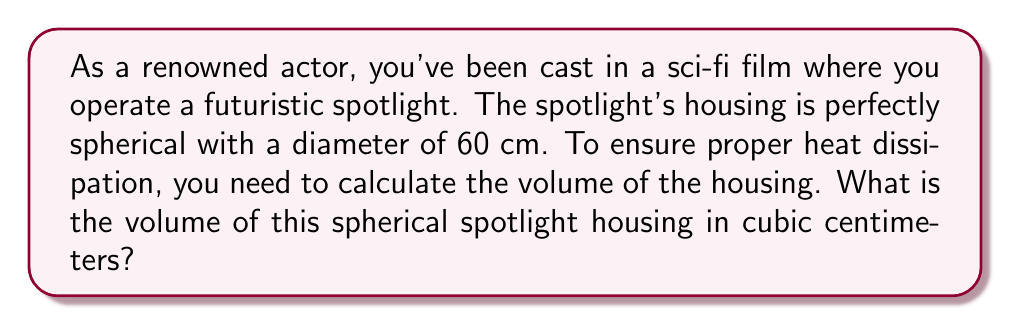Solve this math problem. Let's approach this step-by-step:

1) The formula for the volume of a sphere is:

   $$V = \frac{4}{3}\pi r^3$$

   where $r$ is the radius of the sphere.

2) We're given the diameter, which is 60 cm. The radius is half of this:

   $$r = \frac{60}{2} = 30 \text{ cm}$$

3) Now, let's substitute this into our volume formula:

   $$V = \frac{4}{3}\pi (30)^3$$

4) Simplify the exponent:

   $$V = \frac{4}{3}\pi (27000)$$

5) Multiply:

   $$V = 36000\pi$$

6) If we use $\pi \approx 3.14159$, we get:

   $$V \approx 113097.6 \text{ cm}^3$$

7) Rounding to the nearest whole number:

   $$V \approx 113098 \text{ cm}^3$$
Answer: $113098 \text{ cm}^3$ 